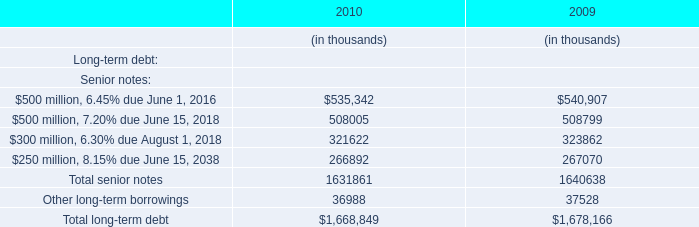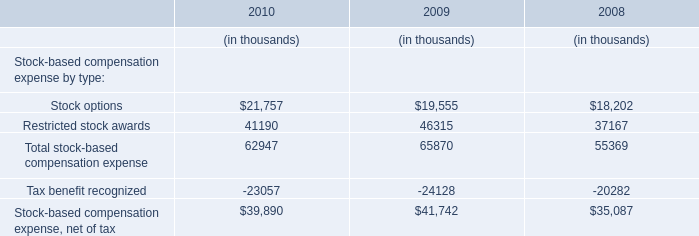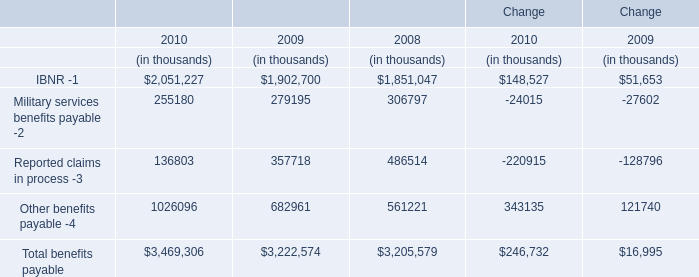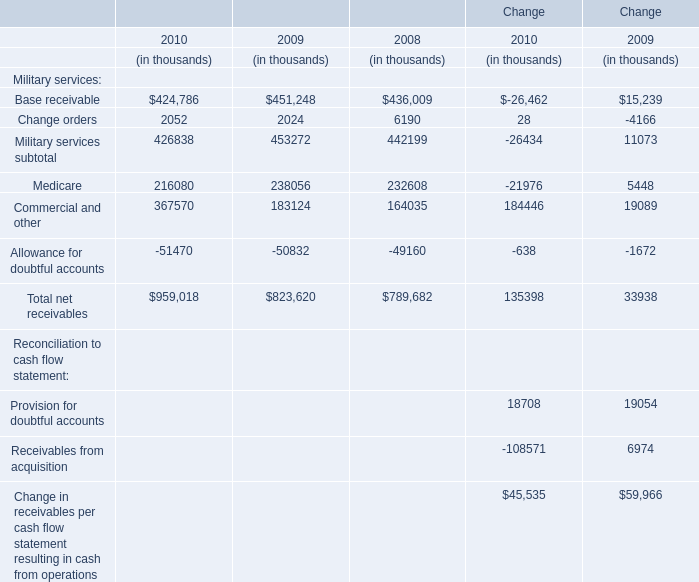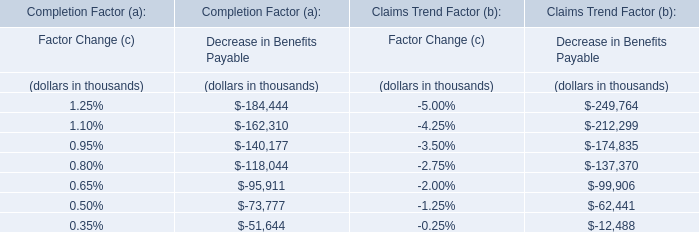Does the value of IBNR in 2009 greater than that in 2010? 
Answer: no. 